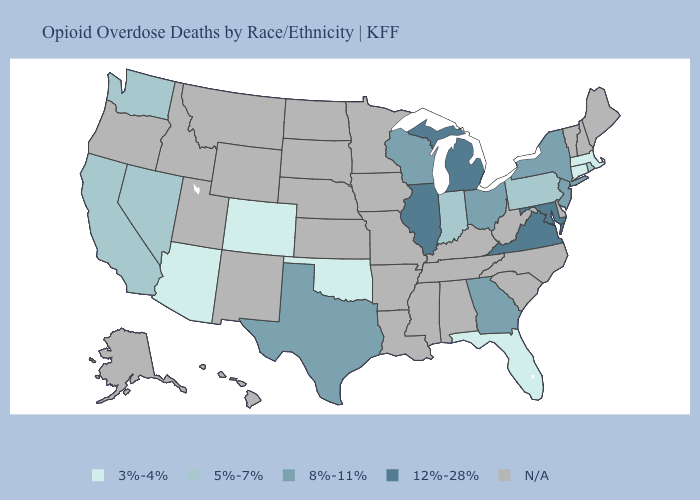Does Wisconsin have the highest value in the MidWest?
Give a very brief answer. No. What is the highest value in the USA?
Write a very short answer. 12%-28%. What is the highest value in the MidWest ?
Quick response, please. 12%-28%. What is the highest value in the USA?
Be succinct. 12%-28%. What is the value of Idaho?
Answer briefly. N/A. Among the states that border Oklahoma , which have the lowest value?
Be succinct. Colorado. Name the states that have a value in the range 8%-11%?
Write a very short answer. Georgia, New Jersey, New York, Ohio, Texas, Wisconsin. What is the value of Arkansas?
Short answer required. N/A. What is the value of Hawaii?
Be succinct. N/A. How many symbols are there in the legend?
Be succinct. 5. Does the map have missing data?
Answer briefly. Yes. Does the first symbol in the legend represent the smallest category?
Short answer required. Yes. Name the states that have a value in the range N/A?
Be succinct. Alabama, Alaska, Arkansas, Delaware, Hawaii, Idaho, Iowa, Kansas, Kentucky, Louisiana, Maine, Minnesota, Mississippi, Missouri, Montana, Nebraska, New Hampshire, New Mexico, North Carolina, North Dakota, Oregon, South Carolina, South Dakota, Tennessee, Utah, Vermont, West Virginia, Wyoming. Does Massachusetts have the lowest value in the Northeast?
Concise answer only. Yes. Does California have the highest value in the West?
Quick response, please. Yes. 